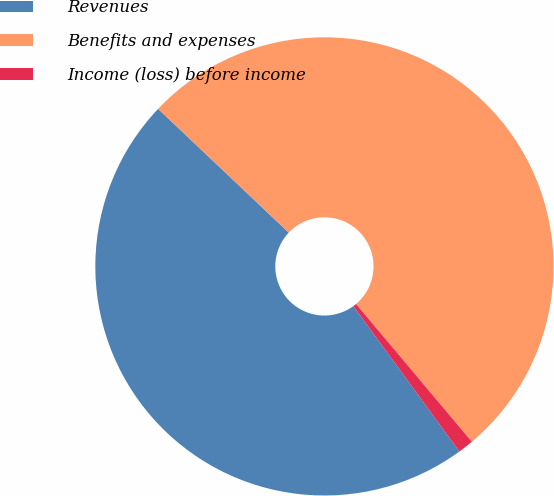Convert chart. <chart><loc_0><loc_0><loc_500><loc_500><pie_chart><fcel>Revenues<fcel>Benefits and expenses<fcel>Income (loss) before income<nl><fcel>47.1%<fcel>51.81%<fcel>1.1%<nl></chart> 